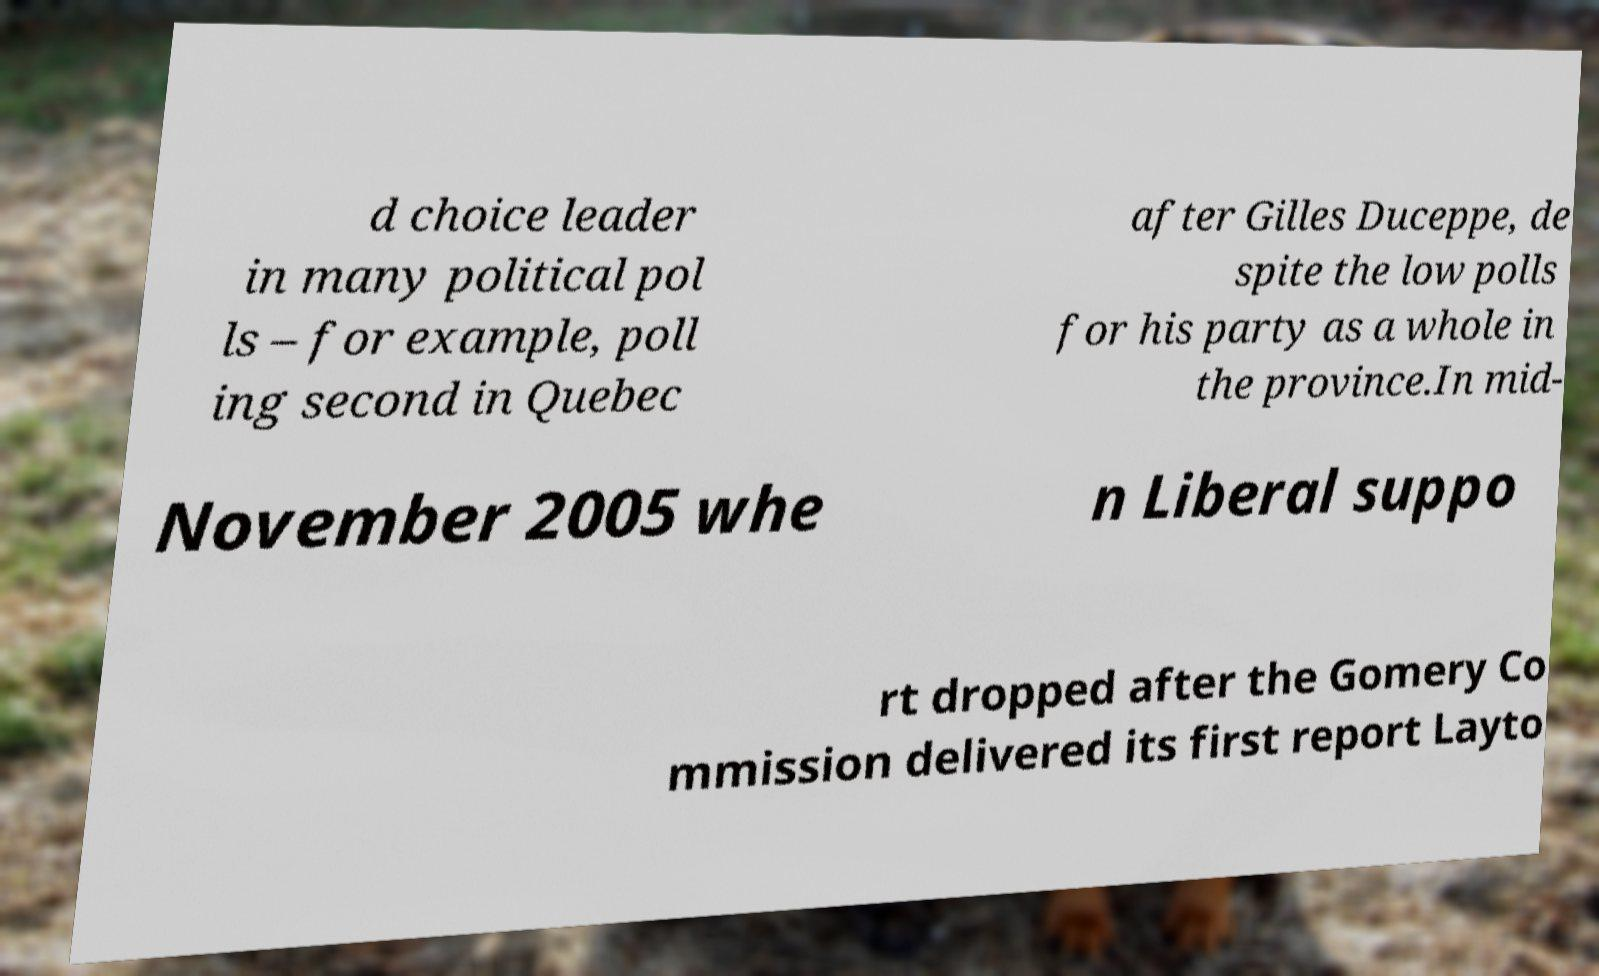Please read and relay the text visible in this image. What does it say? d choice leader in many political pol ls – for example, poll ing second in Quebec after Gilles Duceppe, de spite the low polls for his party as a whole in the province.In mid- November 2005 whe n Liberal suppo rt dropped after the Gomery Co mmission delivered its first report Layto 